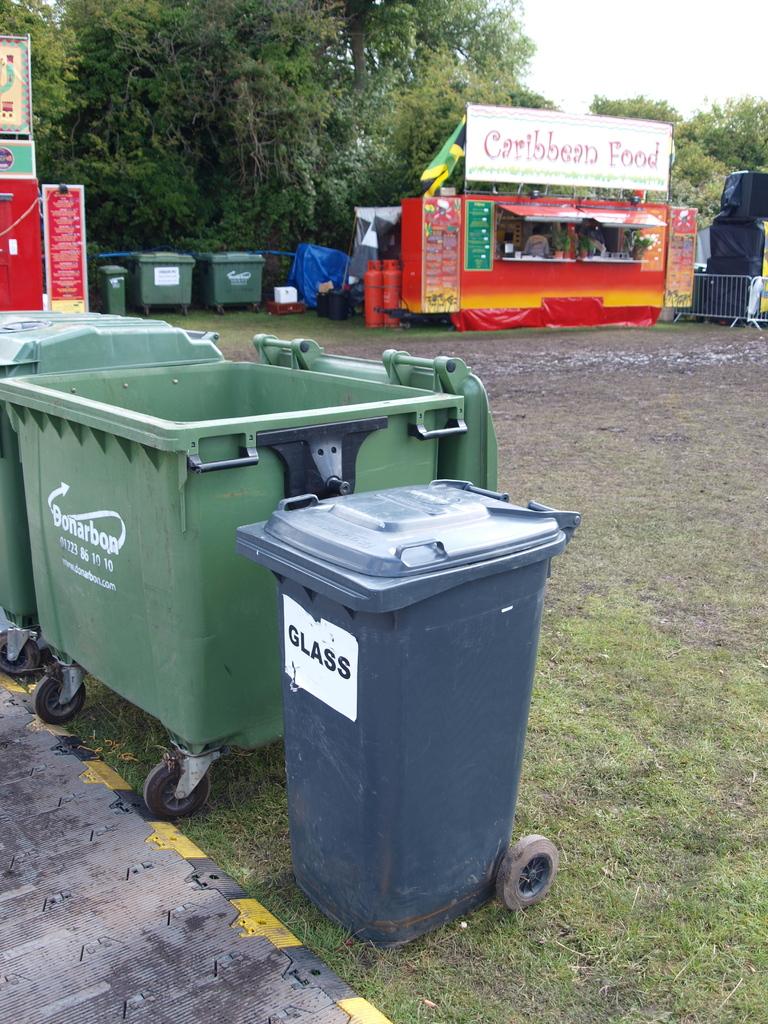What is the blue bin for?
Provide a succinct answer. Glass. What type of food is served at the red booth?
Give a very brief answer. Caribbean. 